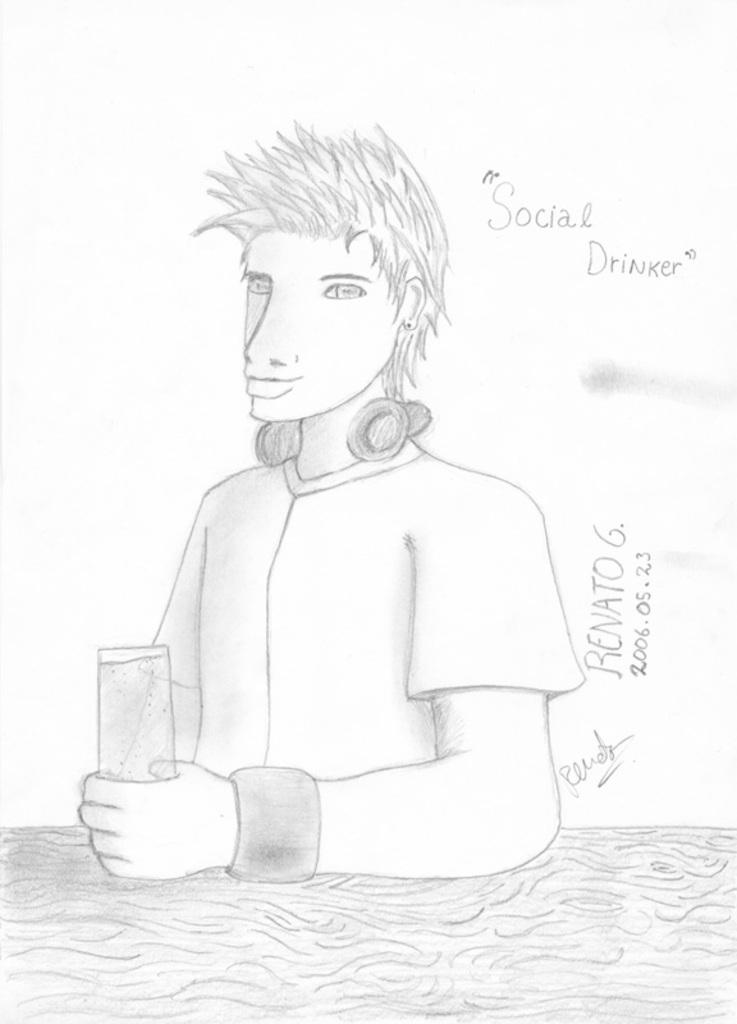What is the main subject of the picture? The main subject of the picture is a drawing. What is the person in the picture holding? The person is holding a glass in the picture. Are there any words or letters in the picture? Yes, there is text in the picture. Can you tell me how much water is in the vase in the picture? There is no vase present in the image, so it is not possible to determine the amount of water in it. 